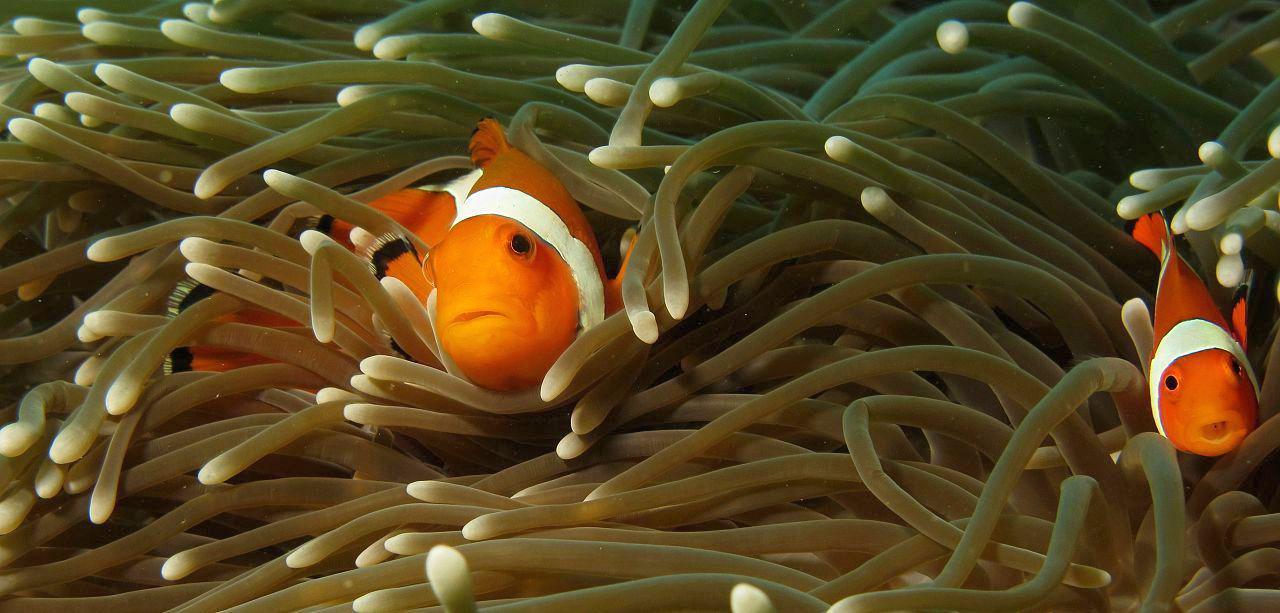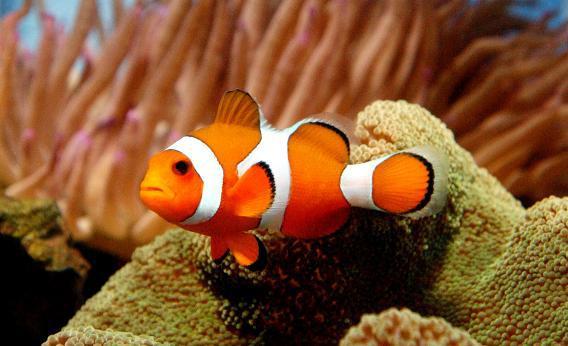The first image is the image on the left, the second image is the image on the right. Examine the images to the left and right. Is the description "Each image contains the same number of clown fish swimming among anemone tendrils." accurate? Answer yes or no. No. The first image is the image on the left, the second image is the image on the right. For the images shown, is this caption "One single fish is swimming in the image on the right." true? Answer yes or no. Yes. 